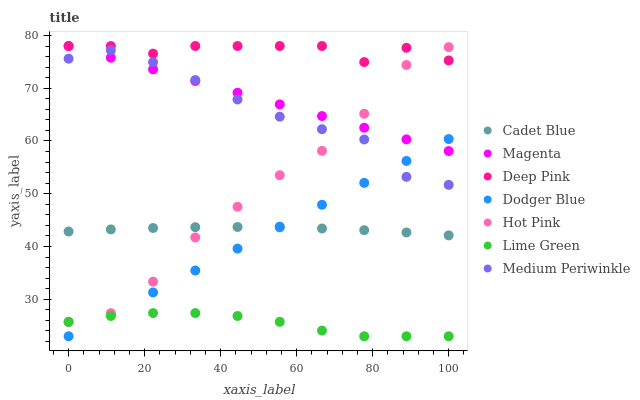Does Lime Green have the minimum area under the curve?
Answer yes or no. Yes. Does Deep Pink have the maximum area under the curve?
Answer yes or no. Yes. Does Hot Pink have the minimum area under the curve?
Answer yes or no. No. Does Hot Pink have the maximum area under the curve?
Answer yes or no. No. Is Dodger Blue the smoothest?
Answer yes or no. Yes. Is Hot Pink the roughest?
Answer yes or no. Yes. Is Medium Periwinkle the smoothest?
Answer yes or no. No. Is Medium Periwinkle the roughest?
Answer yes or no. No. Does Dodger Blue have the lowest value?
Answer yes or no. Yes. Does Hot Pink have the lowest value?
Answer yes or no. No. Does Magenta have the highest value?
Answer yes or no. Yes. Does Hot Pink have the highest value?
Answer yes or no. No. Is Dodger Blue less than Deep Pink?
Answer yes or no. Yes. Is Magenta greater than Lime Green?
Answer yes or no. Yes. Does Medium Periwinkle intersect Dodger Blue?
Answer yes or no. Yes. Is Medium Periwinkle less than Dodger Blue?
Answer yes or no. No. Is Medium Periwinkle greater than Dodger Blue?
Answer yes or no. No. Does Dodger Blue intersect Deep Pink?
Answer yes or no. No. 